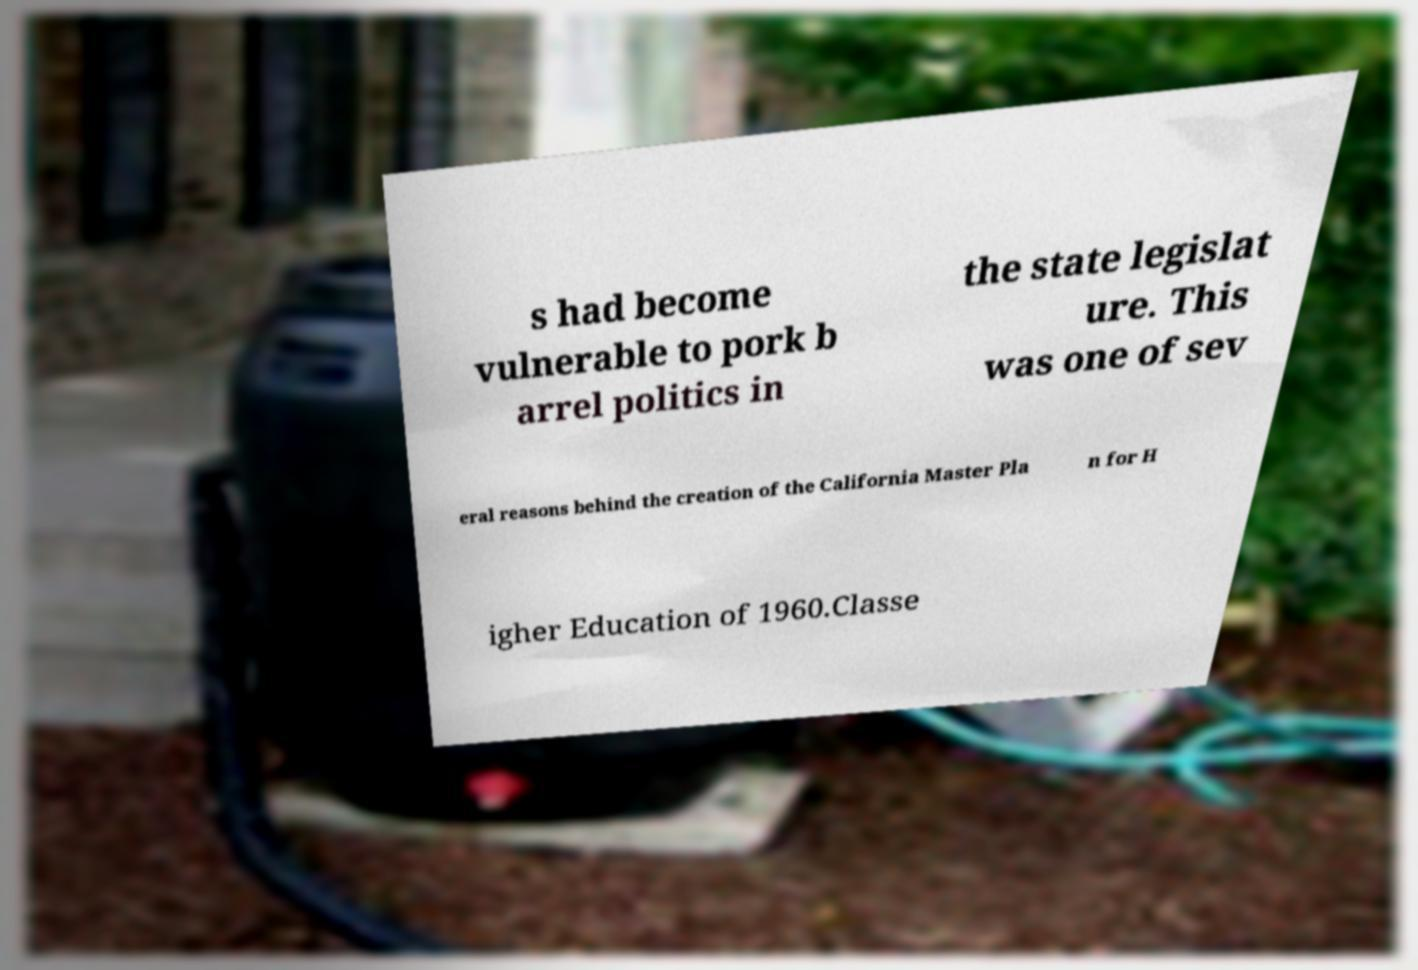There's text embedded in this image that I need extracted. Can you transcribe it verbatim? s had become vulnerable to pork b arrel politics in the state legislat ure. This was one of sev eral reasons behind the creation of the California Master Pla n for H igher Education of 1960.Classe 